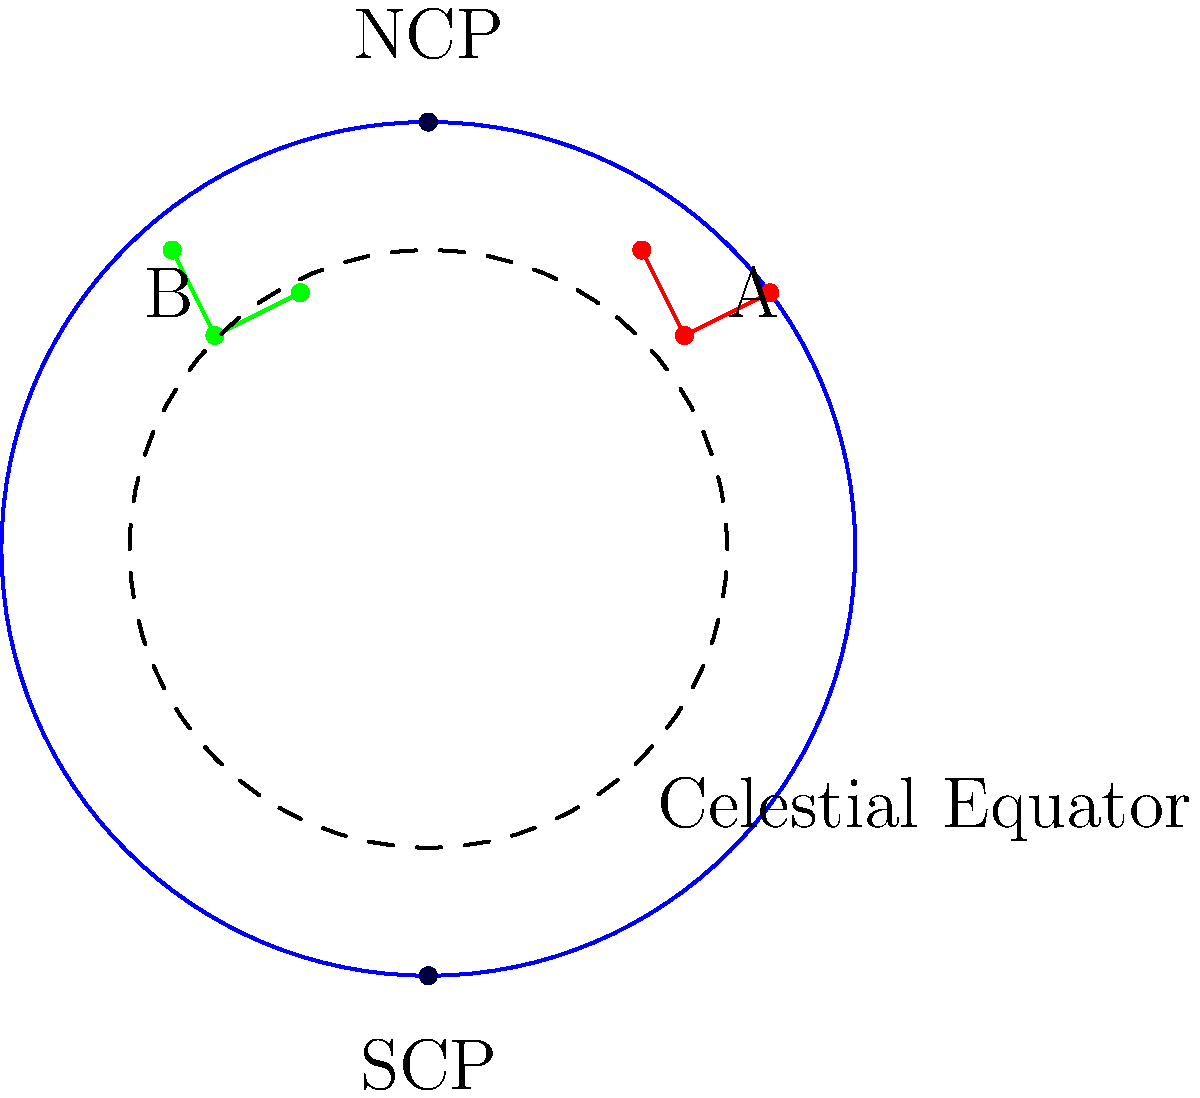In the ancient star map shown above, constellation A is located entirely in the northern celestial hemisphere, while constellation B straddles the celestial equator. Based on this information and your knowledge of ancient astronomical observations, which of these constellations would have been more useful for ancient navigators sailing near the equator, and why? To answer this question, we need to consider the following steps:

1. Understand the celestial sphere:
   - The celestial equator divides the sky into northern and southern hemispheres.
   - The North Celestial Pole (NCP) and South Celestial Pole (SCP) are fixed points in the sky.

2. Analyze the positions of the constellations:
   - Constellation A is entirely in the northern hemisphere.
   - Constellation B straddles the celestial equator, with parts in both hemispheres.

3. Consider the perspective of equatorial navigation:
   - Ships sailing near the equator would see both the northern and southern skies.
   - The celestial equator would appear high in the sky, near the zenith.

4. Evaluate the usefulness of each constellation:
   - Constellation A:
     - Always visible in the northern sky
     - Changes position throughout the night
     - Not ideal for determining latitude near the equator
   - Constellation B:
     - Straddles the celestial equator
     - Visible in both hemispheres
     - Rises due east and sets due west
     - Provides a consistent reference point for east-west navigation

5. Conclude based on navigational utility:
   - Constellation B would be more useful because:
     - It provides a reliable east-west reference
     - It helps in determining the direction of the celestial poles
     - It's visible from both hemispheres, making it consistently useful near the equator

Therefore, Constellation B would have been more valuable for ancient navigators sailing near the equator due to its position straddling the celestial equator, providing consistent and reliable navigational information regardless of the observer's position relative to the equator.
Answer: Constellation B, due to its position straddling the celestial equator. 